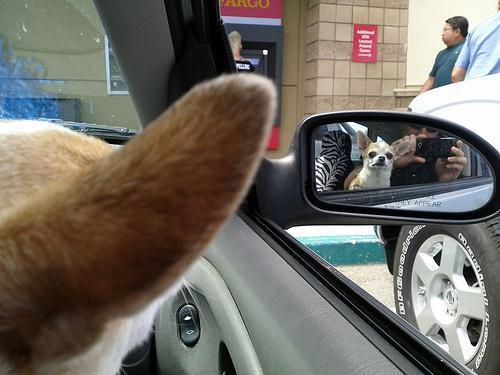How many cars are in the photo?
Give a very brief answer. 2. 